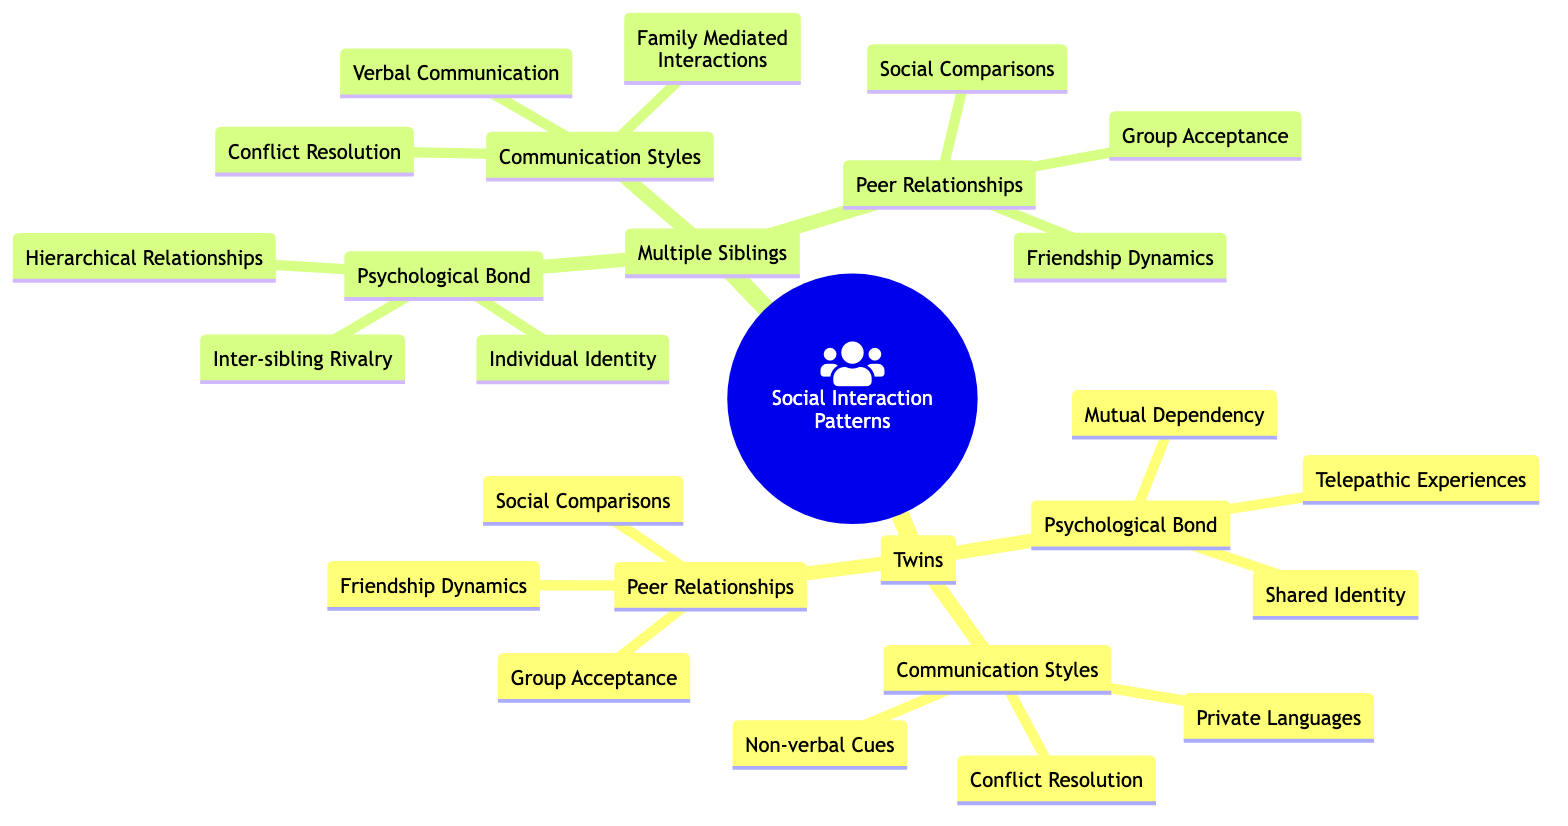What are the three components of the psychological bond among twins? The diagram lists three sub-elements under the psychological bond for twins: shared identity, mutual dependency, and telepathic experiences.
Answer: Shared Identity, Mutual Dependency, Telepathic Experiences How many elements are there under communication styles for multiple siblings? The communication styles for multiple siblings have three distinct elements: verbal communication, family mediated interactions, and conflict resolution. Counting these gives a total of three elements.
Answer: 3 Which group interacts through private languages? The sub-element "Private Languages" appears under the communication styles of twins, indicating that twins often have unique communication methods distinct from multiple siblings.
Answer: Twins What type of identity is emphasized in the psychological bond of multiple siblings? The diagram specifies "Individual Identity" as a key element under the psychological bond for multiple siblings, highlighting the individuality nurtured among them.
Answer: Individual Identity How do the peer relationships differ between twins and multiple siblings concerning hierarchical relationships? The diagram shows that twins do not have hierarchical relationships as a part of their psychological bond, whereas multiple siblings do, indicating a structural difference in peer dynamics.
Answer: Hierarchical Relationships Which communication style is common to both twins and multiple siblings? Both categories list "Conflict Resolution" as a shared element within their communication styles, reflecting a common approach to resolving disagreements.
Answer: Conflict Resolution What is a unique experience noted for twins in their psychological bond? The unique experience highlighted for twins in their psychological bond is "Telepathic Experiences," which is not mentioned for multiple siblings at all.
Answer: Telepathic Experiences What relationship dynamic is included in the psychological bond for multiple siblings? The diagram lists "Hierarchical Relationships" as part of the psychological bond in multiple siblings, indicating a structured dynamic among siblings based on age or status.
Answer: Hierarchical Relationships Which aspect of peer relationships is present in both twins and multiple siblings? Both twins and multiple siblings include "Friendship Dynamics" as a shared aspect of their peer relationships, indicating the importance of friendships for both groups.
Answer: Friendship Dynamics 